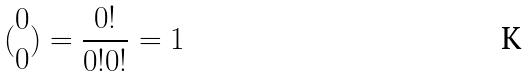Convert formula to latex. <formula><loc_0><loc_0><loc_500><loc_500>( \begin{matrix} 0 \\ 0 \end{matrix} ) = \frac { 0 ! } { 0 ! 0 ! } = 1</formula> 